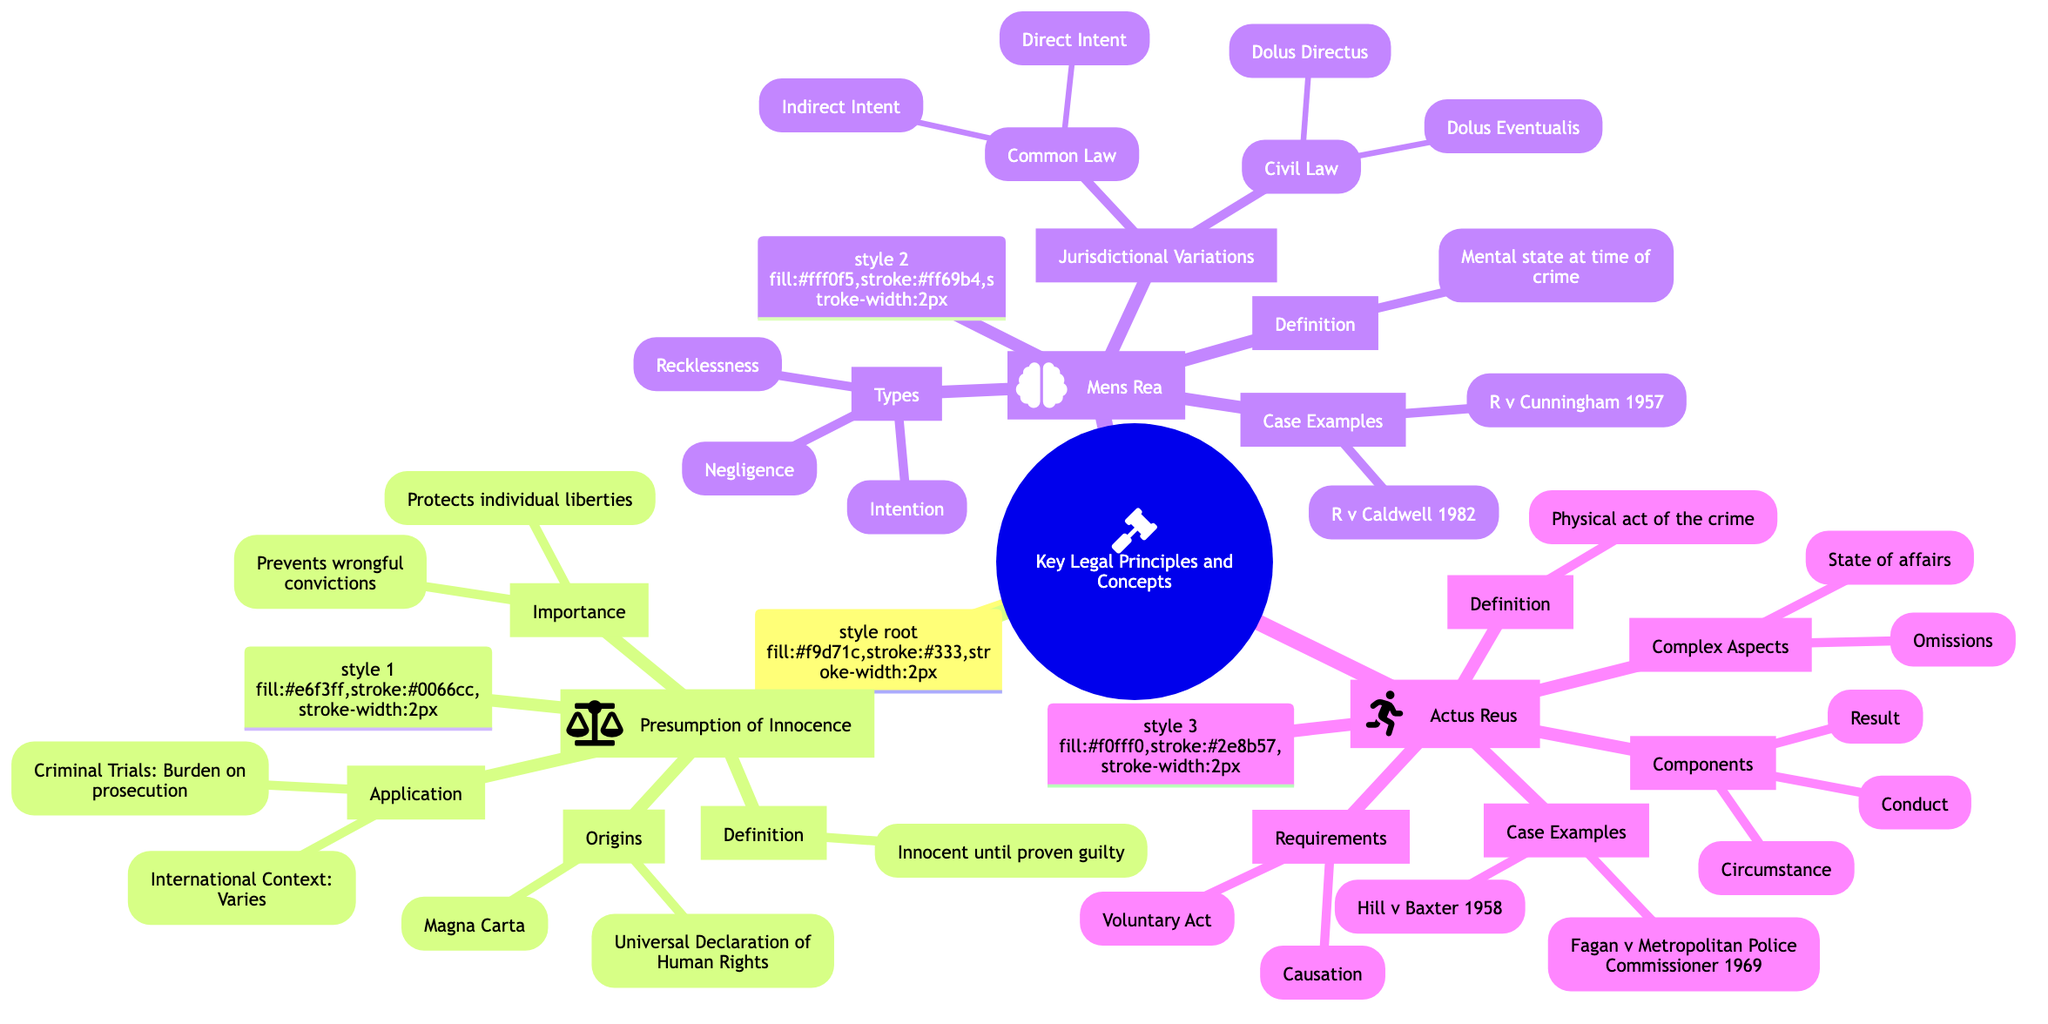What is the definition of the Presumption of Innocence? According to the diagram, the Presumption of Innocence is defined as the legal principle that one is considered innocent until proven guilty.
Answer: Innocent until proven guilty What are the types of Mens Rea listed in the mind map? The mind map lists three types of Mens Rea: Intention, Recklessness, and Negligence.
Answer: Intention, Recklessness, Negligence How many origins are listed for the Presumption of Innocence? The diagram shows two origins for the Presumption of Innocence: Magna Carta and Universal Declaration of Human Rights, which makes a total of two.
Answer: 2 What is a requirement for Actus Reus according to the mind map? The mind map states that a requirement for Actus Reus is a Voluntary Act, which is one of the key components necessary for establishing that a crime has occurred.
Answer: Voluntary Act What case examples are associated with Mens Rea in the mind map? The mind map includes R v Cunningham (1957) and R v Caldwell (1982) as case examples that illustrate the concept of Mens Rea.
Answer: R v Cunningham (1957), R v Caldwell (1982) Which legal principle has an application that states "Burden of proof lies with the prosecution"? The application stating "Burden of proof lies with the prosecution" is associated with the Presumption of Innocence principle as per the diagram.
Answer: Presumption of Innocence How many components are listed under Actus Reus? There are three components listed under Actus Reus: Conduct, Result, and Circumstance, so the total is three components.
Answer: 3 What is the significance of the Presumption of Innocence in legal contexts? The mind map highlights two significant points regarding the Presumption of Innocence: it protects individual liberties and prevents wrongful convictions, which emphasize its importance in legal systems.
Answer: Protects individual liberties, Prevents wrongful convictions What are the jurisdictional variations of Mens Rea in Civil Law? The mind map lists two jurisdictional variations in Civil Law for Mens Rea: Dolus Directus and Dolus Eventualis.
Answer: Dolus Directus, Dolus Eventualis 